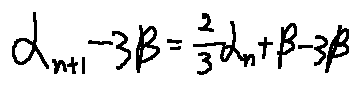Convert formula to latex. <formula><loc_0><loc_0><loc_500><loc_500>\alpha _ { n + 1 } - 3 \beta = \frac { 2 } { 3 } \alpha _ { n } + \beta - 3 \beta</formula> 